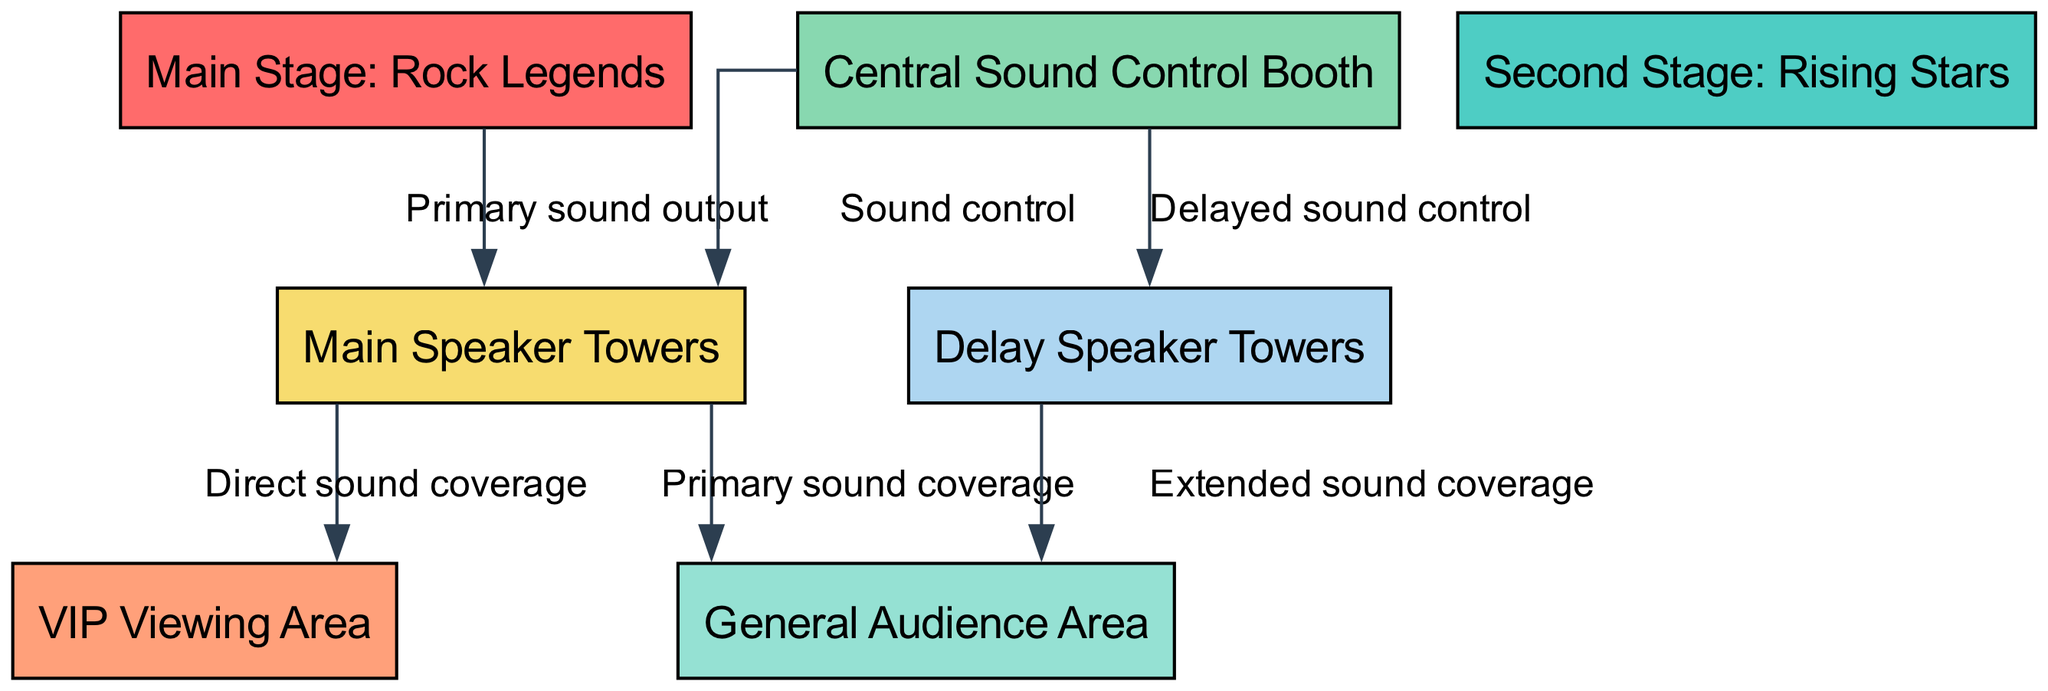What are the names of the stages? The diagram includes two stages: the Main Stage labeled as "Rock Legends" and the Second Stage labeled as "Rising Stars." These names are derived directly from the labels assigned to each respective node in the diagram.
Answer: Rock Legends, Rising Stars How many audience areas are there? The diagram features two distinct audience areas: the VIP Viewing Area and the General Audience Area. This can be determined by counting the audience-related nodes present in the data structure.
Answer: 2 Which area receives direct sound coverage from the main speaker towers? The Main Speaker Towers provide direct sound coverage to both the VIP Viewing Area and the General Audience Area, as indicated by the connections shown in the edges of the diagram. Focusing on the edge from speaker towers to each audience area confirms this relationship.
Answer: VIP Viewing Area, General Audience Area What is the purpose of the delay speaker towers? The Delay Speaker Towers are designated for providing extended sound coverage to the General Audience. This can be identified by the specific edge pointing from the delay towers to the General Audience area in the diagram.
Answer: Extended sound coverage How is sound controlled at the music festival? Sound control is managed centrally from the Sound Control Booth, which connects to both the Main Speaker Towers for primary sound output and the Delay Speaker Towers for delayed sound control. Analyzing the edges from the sound booth illustrates its controlling role in sound management.
Answer: Central Sound Control Booth Which area is closest to the Main Stage in terms of sound coverage? The Main Speaker Towers directly cover both the VIP Area and the General Audience Area, indicating that these areas receive the coverage closest to the Main Stage. The specific relationship can be confirmed by examining the edges leading from the speaker towers to each area.
Answer: VIP Viewing Area, General Audience Area What is the color representing the sound booth in the diagram? In the diagram, the Central Sound Control Booth node is represented in a specific color, which is light green (#88D8B0 as per the color scheme). This color can be identified by examining the properties assigned to that particular node in the data structure.
Answer: Light green How many edges connect to the Main Stage? The Main Stage has one edge connecting to the Main Speaker Towers, which facilitates primary sound output. By counting the connections indicated in the edges, it confirms the singular relationship stemming from this stage.
Answer: 1 